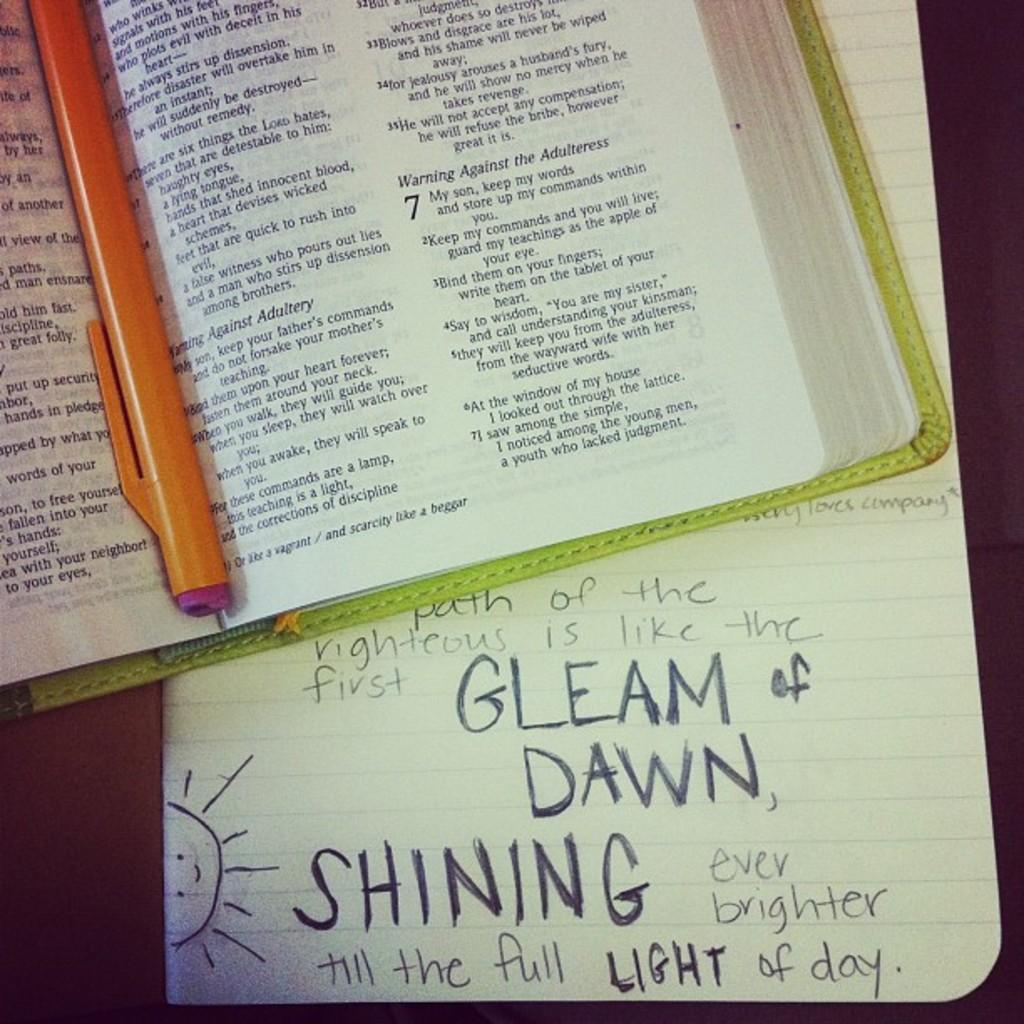Provide a one-sentence caption for the provided image. Someone has scribbled Gleam of Dawn and Shining Light on a piece of paper. 